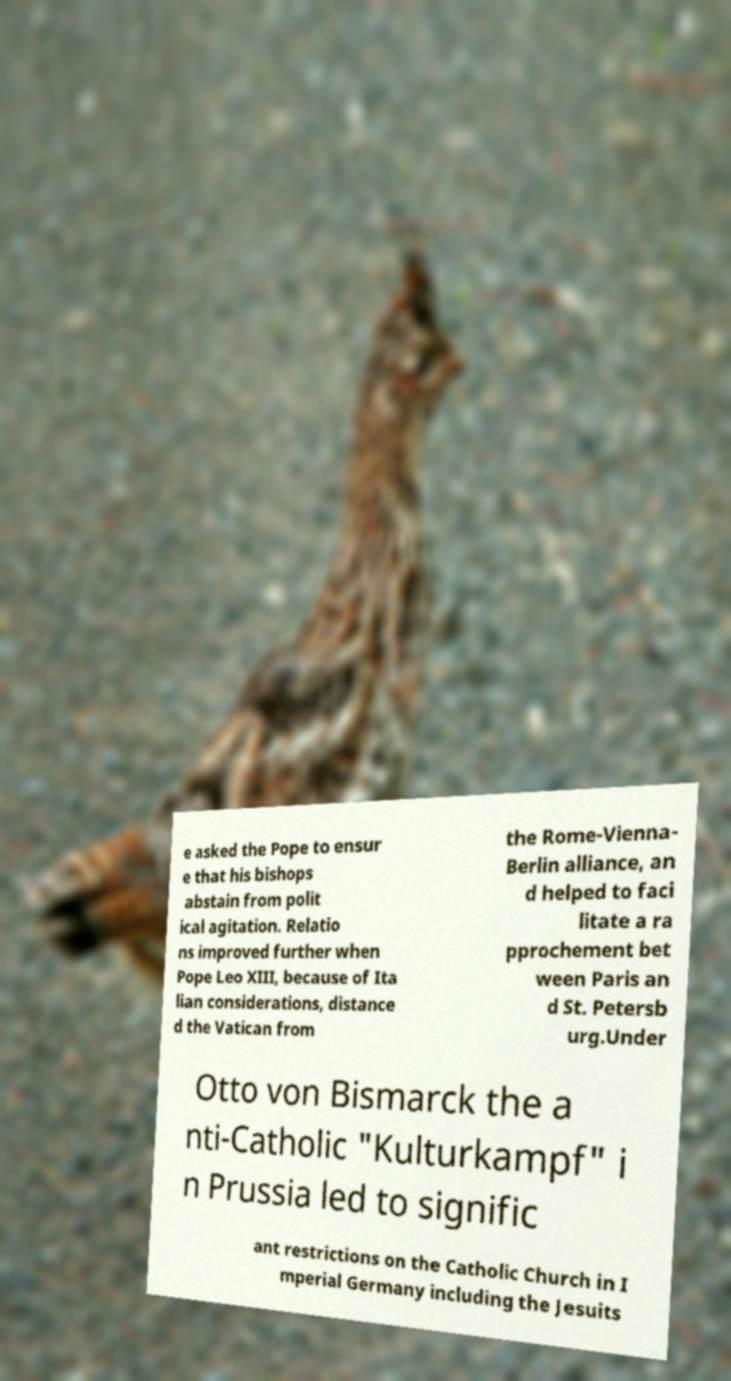There's text embedded in this image that I need extracted. Can you transcribe it verbatim? e asked the Pope to ensur e that his bishops abstain from polit ical agitation. Relatio ns improved further when Pope Leo XIII, because of Ita lian considerations, distance d the Vatican from the Rome-Vienna- Berlin alliance, an d helped to faci litate a ra pprochement bet ween Paris an d St. Petersb urg.Under Otto von Bismarck the a nti-Catholic "Kulturkampf" i n Prussia led to signific ant restrictions on the Catholic Church in I mperial Germany including the Jesuits 